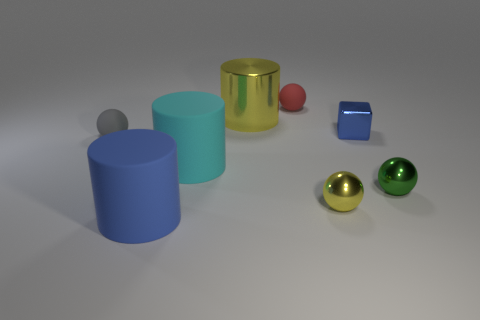Add 1 cyan rubber spheres. How many objects exist? 9 Subtract all cubes. How many objects are left? 7 Subtract 0 green cubes. How many objects are left? 8 Subtract all tiny gray objects. Subtract all rubber spheres. How many objects are left? 5 Add 7 yellow shiny things. How many yellow shiny things are left? 9 Add 3 red things. How many red things exist? 4 